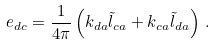<formula> <loc_0><loc_0><loc_500><loc_500>e _ { d c } = \frac { 1 } { 4 \pi } \left ( k _ { d a } \tilde { l } _ { c a } + k _ { c a } \tilde { l } _ { d a } \right ) \, .</formula> 